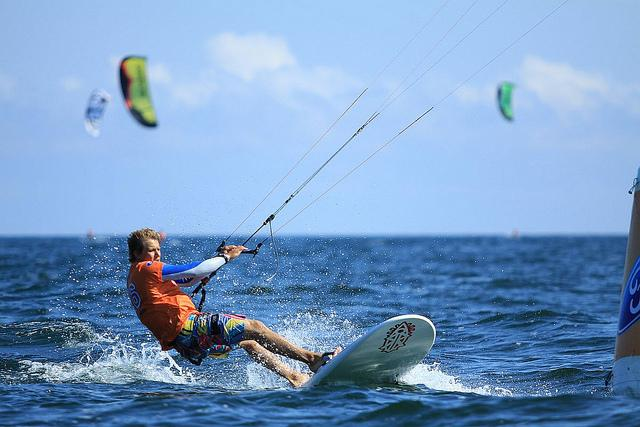The man who received the first patent for this sport was from which country? netherlands 